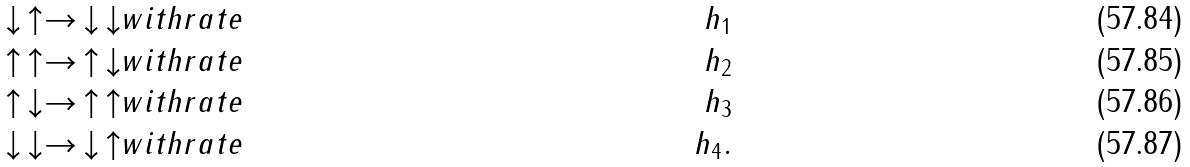Convert formula to latex. <formula><loc_0><loc_0><loc_500><loc_500>\downarrow \, \uparrow \to \, \downarrow \, \downarrow & w i t h r a t e & h _ { 1 } \\ \uparrow \, \uparrow \to \, \uparrow \, \downarrow & w i t h r a t e & h _ { 2 } \\ \uparrow \, \downarrow \to \, \uparrow \, \uparrow & w i t h r a t e & h _ { 3 } \\ \downarrow \, \downarrow \to \, \downarrow \, \uparrow & w i t h r a t e & h _ { 4 } .</formula> 